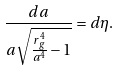Convert formula to latex. <formula><loc_0><loc_0><loc_500><loc_500>\frac { d a } { a \sqrt { \frac { r ^ { 4 } _ { g } } { a ^ { 4 } } - 1 } } = d \eta .</formula> 